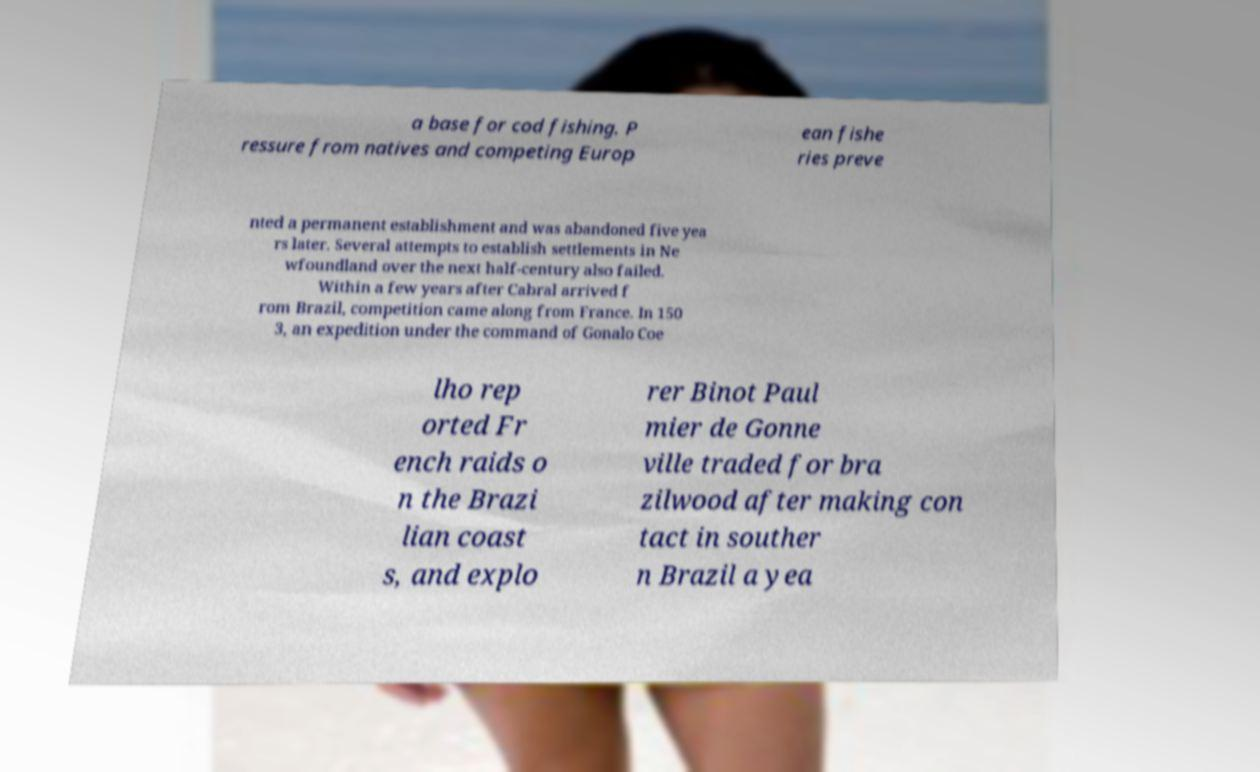Could you extract and type out the text from this image? a base for cod fishing. P ressure from natives and competing Europ ean fishe ries preve nted a permanent establishment and was abandoned five yea rs later. Several attempts to establish settlements in Ne wfoundland over the next half-century also failed. Within a few years after Cabral arrived f rom Brazil, competition came along from France. In 150 3, an expedition under the command of Gonalo Coe lho rep orted Fr ench raids o n the Brazi lian coast s, and explo rer Binot Paul mier de Gonne ville traded for bra zilwood after making con tact in souther n Brazil a yea 